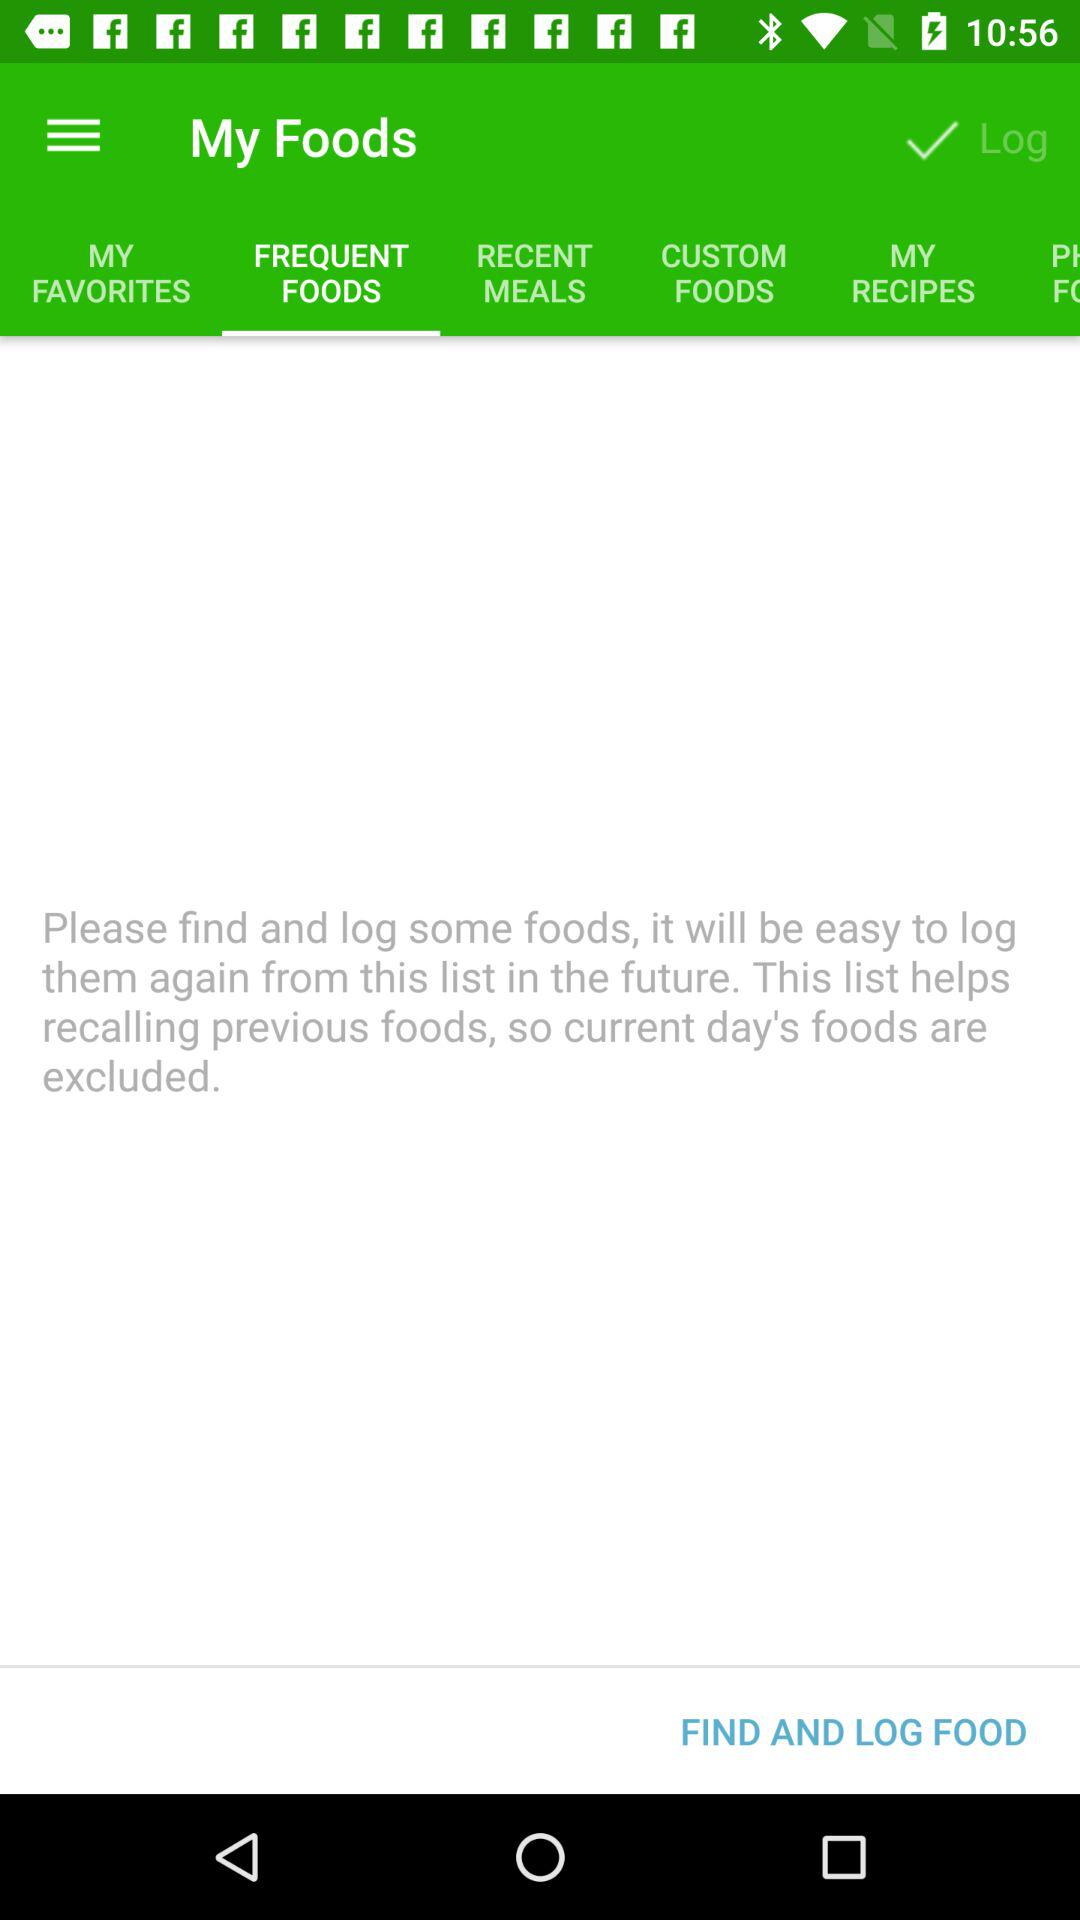Which tab is selected? The selected tab is "FREQUENT FOODS". 